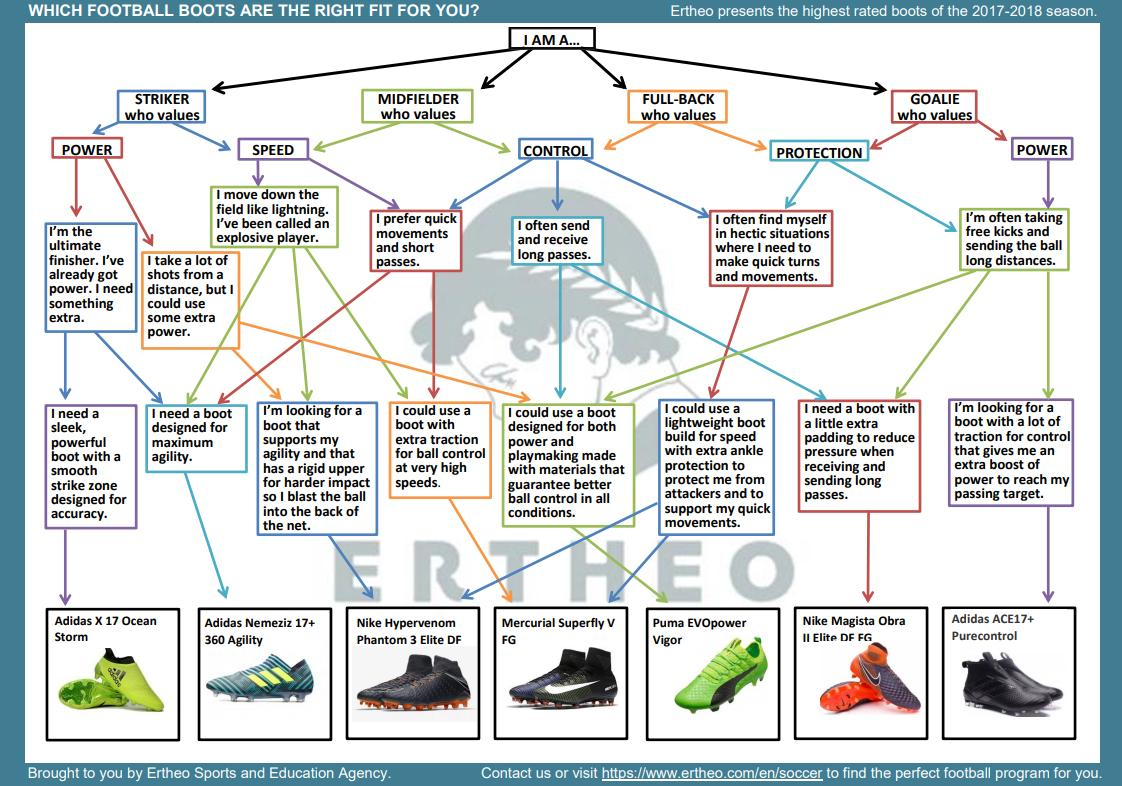Draw attention to some important aspects in this diagram. Adidas Nemeziz 17+ 360 Agility is engineered for maximum agility, providing exceptional control and movement on the pitch. Introducing the Adidas X 17 Ocean Storm boot, featuring a sleek and powerful design with a strike zone optimized for accuracy. This boot is the perfect choice for players who want to dominate on the pitch. There are two green boots displayed. In the image, 7 football boots are prominently displayed. The Nike Magista Obra II Elite DF FG is an orange colored boot. 